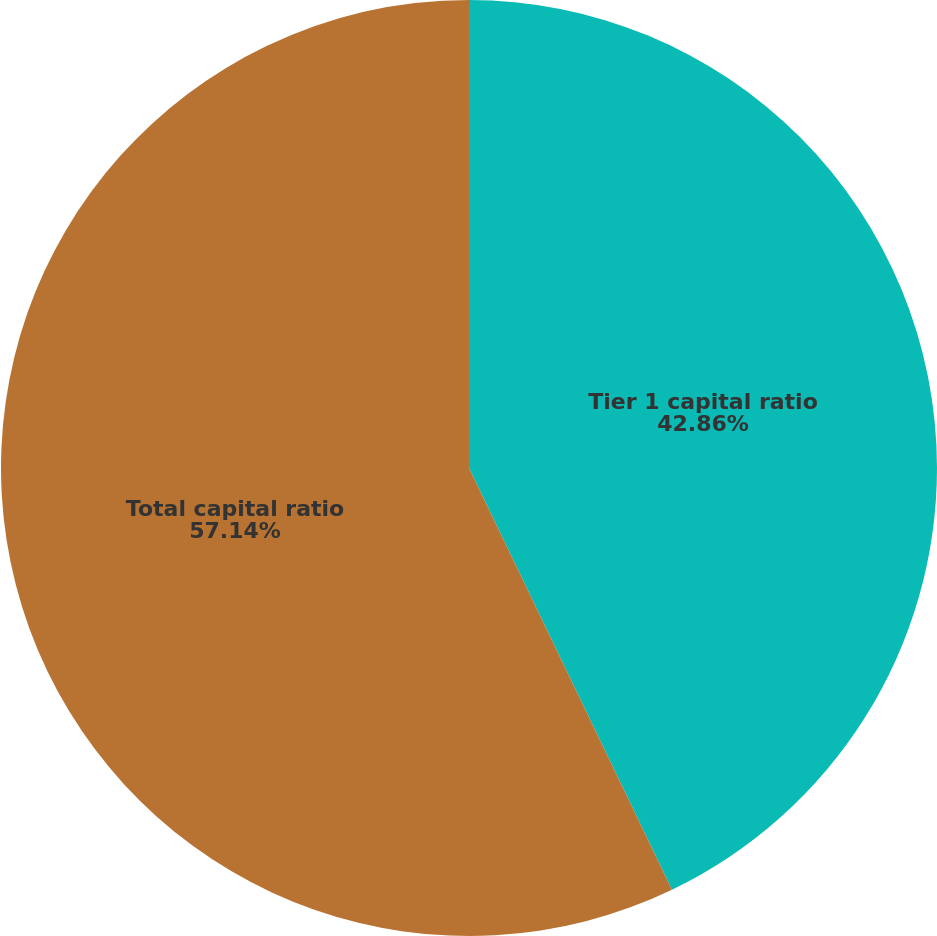<chart> <loc_0><loc_0><loc_500><loc_500><pie_chart><fcel>Tier 1 capital ratio<fcel>Total capital ratio<nl><fcel>42.86%<fcel>57.14%<nl></chart> 